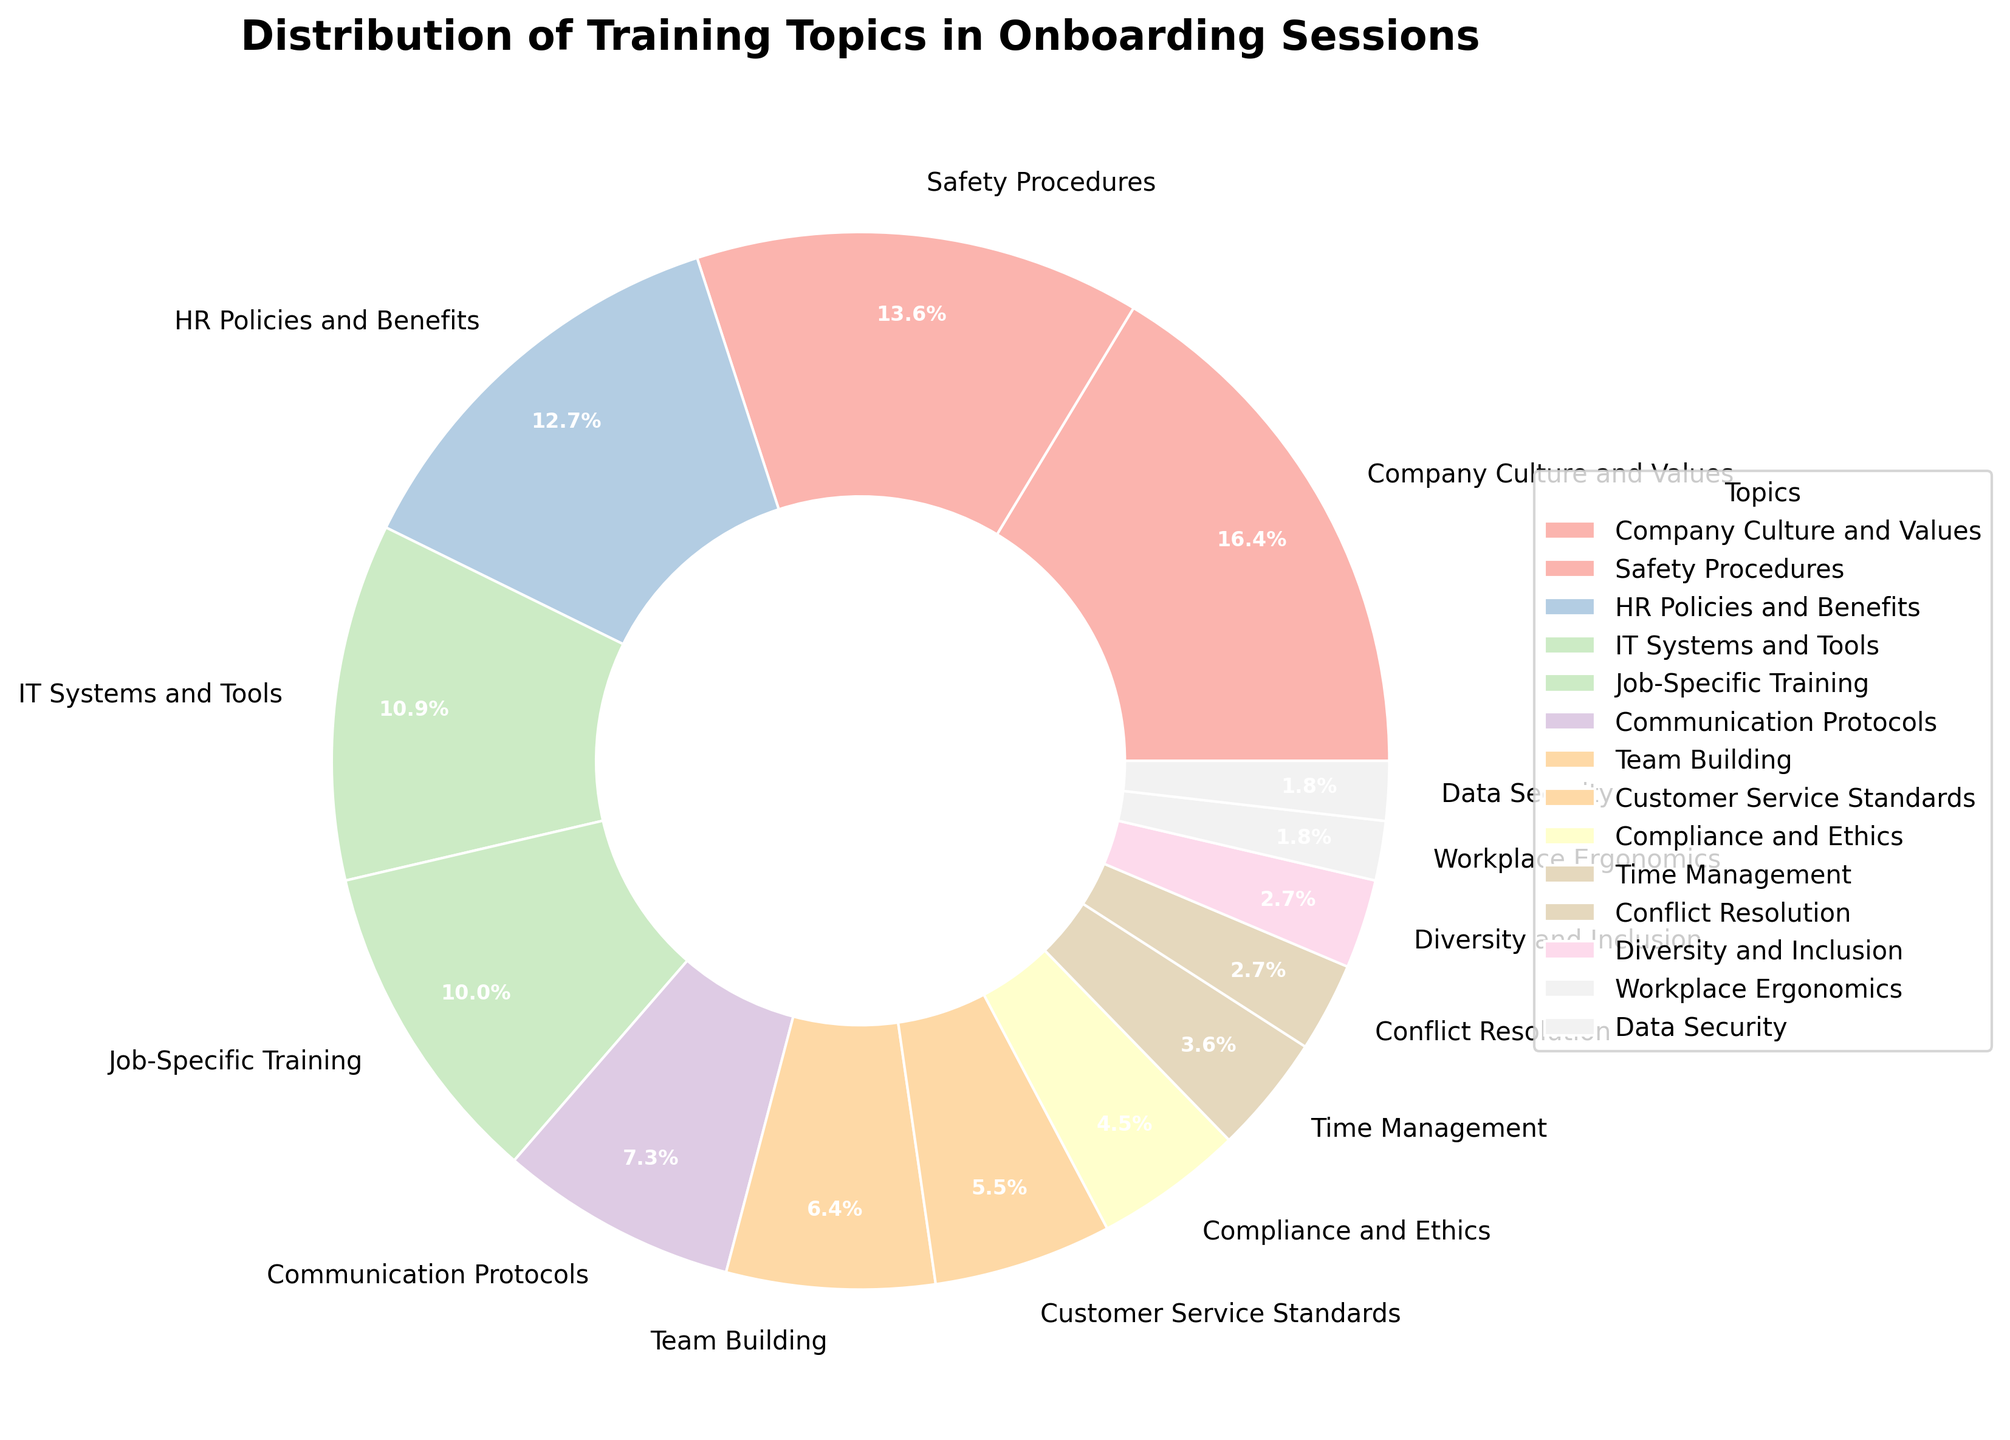Which topic is covered the most in the onboarding sessions? From the pie chart, identify the topic with the largest wedge. "Company Culture and Values" has the largest percentage, indicating it is covered the most.
Answer: Company Culture and Values Which topic is covered the least in the onboarding sessions? From the pie chart, identify the topic with the smallest wedge. "Data Security" and "Workplace Ergonomics" both have the smallest percentages, indicating they are covered the least.
Answer: Data Security and Workplace Ergonomics What is the combined percentage for the topics "Safety Procedures" and "HR Policies and Benefits"? Locate the wedges for "Safety Procedures" and "HR Policies and Benefits." Their percentages are 15% and 14%, respectively. Summing these gives 15% + 14% = 29%.
Answer: 29% How many topics have a coverage of at least 10% each? Identify the wedges with percentages 10% or greater. "Company Culture and Values" (18%), "Safety Procedures" (15%), "HR Policies and Benefits" (14%), "IT Systems and Tools" (12%), and "Job-Specific Training" (11%) meet this criterion. There are 5 such topics.
Answer: 5 Is "Communication Protocols" covered more or less than "Team Building"? Compare the wedges for "Communication Protocols" and "Team Building". "Communication Protocols" is 8%, while "Team Building" is 7%. Therefore, "Communication Protocols" is covered more.
Answer: More What is the percentage difference between "Customer Service Standards" and "Compliance and Ethics"? Identify the wedges and their percentages: "Customer Service Standards" is 6%, and "Compliance and Ethics" is 5%. The difference is 6% - 5% = 1%.
Answer: 1% Which three topics together represent the smallest percentage of the total? Identify the three topics with the smallest wedges and sum their percentages. "Data Security" (2%), "Workplace Ergonomics" (2%), and "Diversity and Inclusion" (3%) sum to 2% + 2% + 3% = 7%.
Answer: Data Security, Workplace Ergonomics, Diversity and Inclusion By how much does "Company Culture and Values" exceed "Communication Protocols" in coverage? Identify the wedges and their percentages: "Company Culture and Values" (18%) and "Communication Protocols" (8%). The difference is 18% - 8% = 10%.
Answer: 10% Which topic is immediately next in frequency after "IT Systems and Tools"? Look at the descending order of the wedges. After "IT Systems and Tools" (12%), the next topic is "Job-Specific Training" (11%).
Answer: Job-Specific Training 